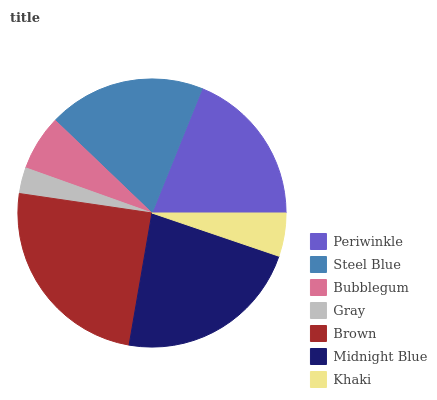Is Gray the minimum?
Answer yes or no. Yes. Is Brown the maximum?
Answer yes or no. Yes. Is Steel Blue the minimum?
Answer yes or no. No. Is Steel Blue the maximum?
Answer yes or no. No. Is Steel Blue greater than Periwinkle?
Answer yes or no. Yes. Is Periwinkle less than Steel Blue?
Answer yes or no. Yes. Is Periwinkle greater than Steel Blue?
Answer yes or no. No. Is Steel Blue less than Periwinkle?
Answer yes or no. No. Is Periwinkle the high median?
Answer yes or no. Yes. Is Periwinkle the low median?
Answer yes or no. Yes. Is Midnight Blue the high median?
Answer yes or no. No. Is Brown the low median?
Answer yes or no. No. 